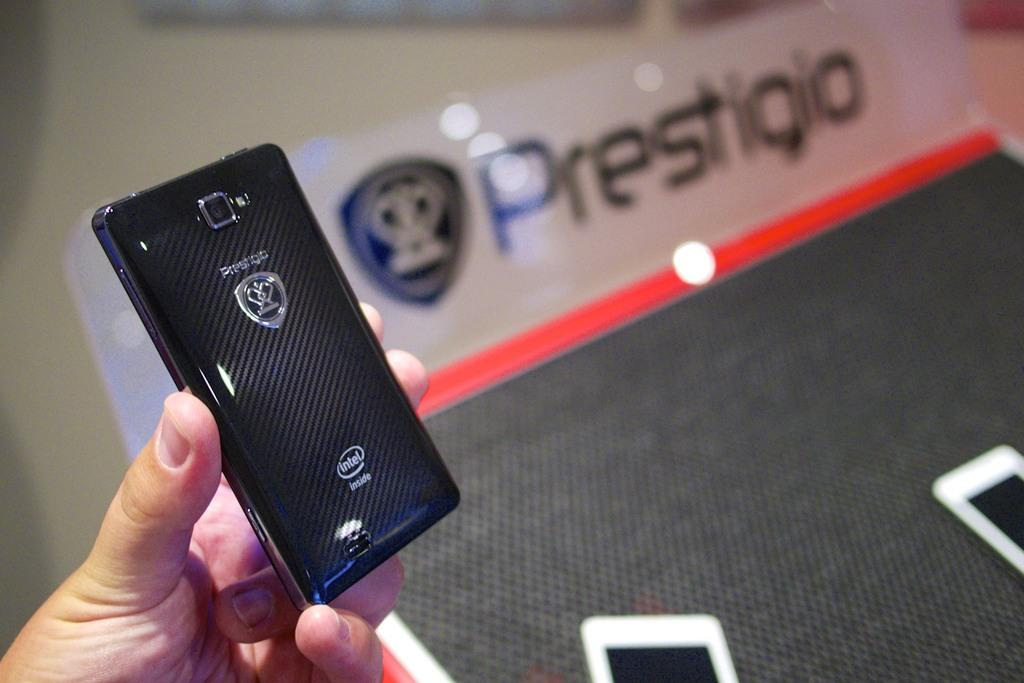<image>
Give a short and clear explanation of the subsequent image. A black electronic device bears the name Prestigio. 